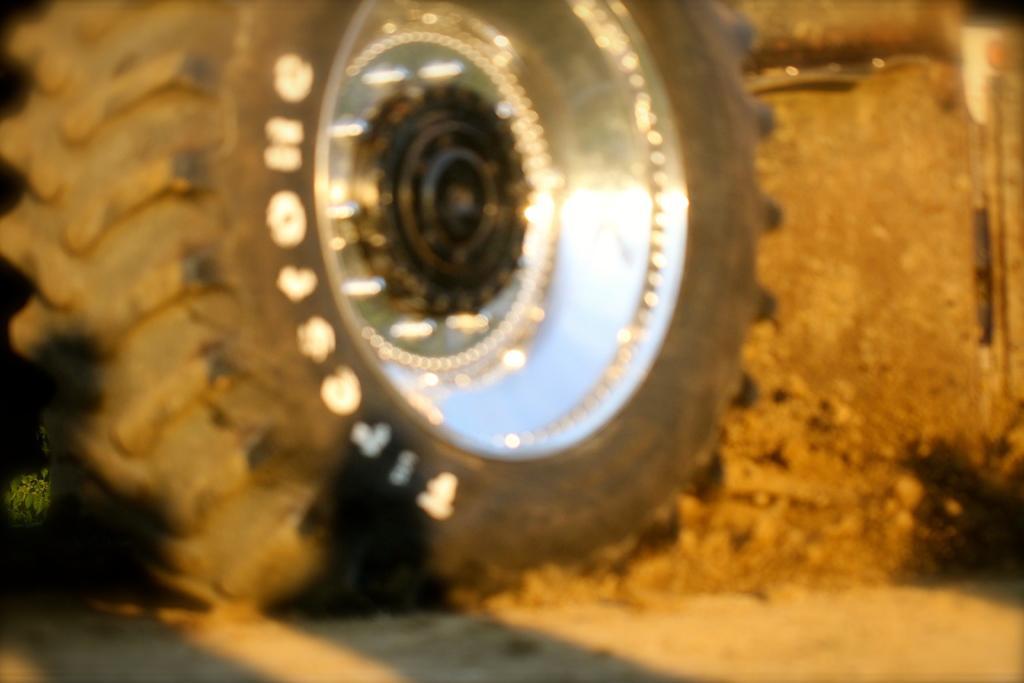Can you describe this image briefly? In this image we can see a wheel of a vehicle on a surface. On the wheel we can see the text. 